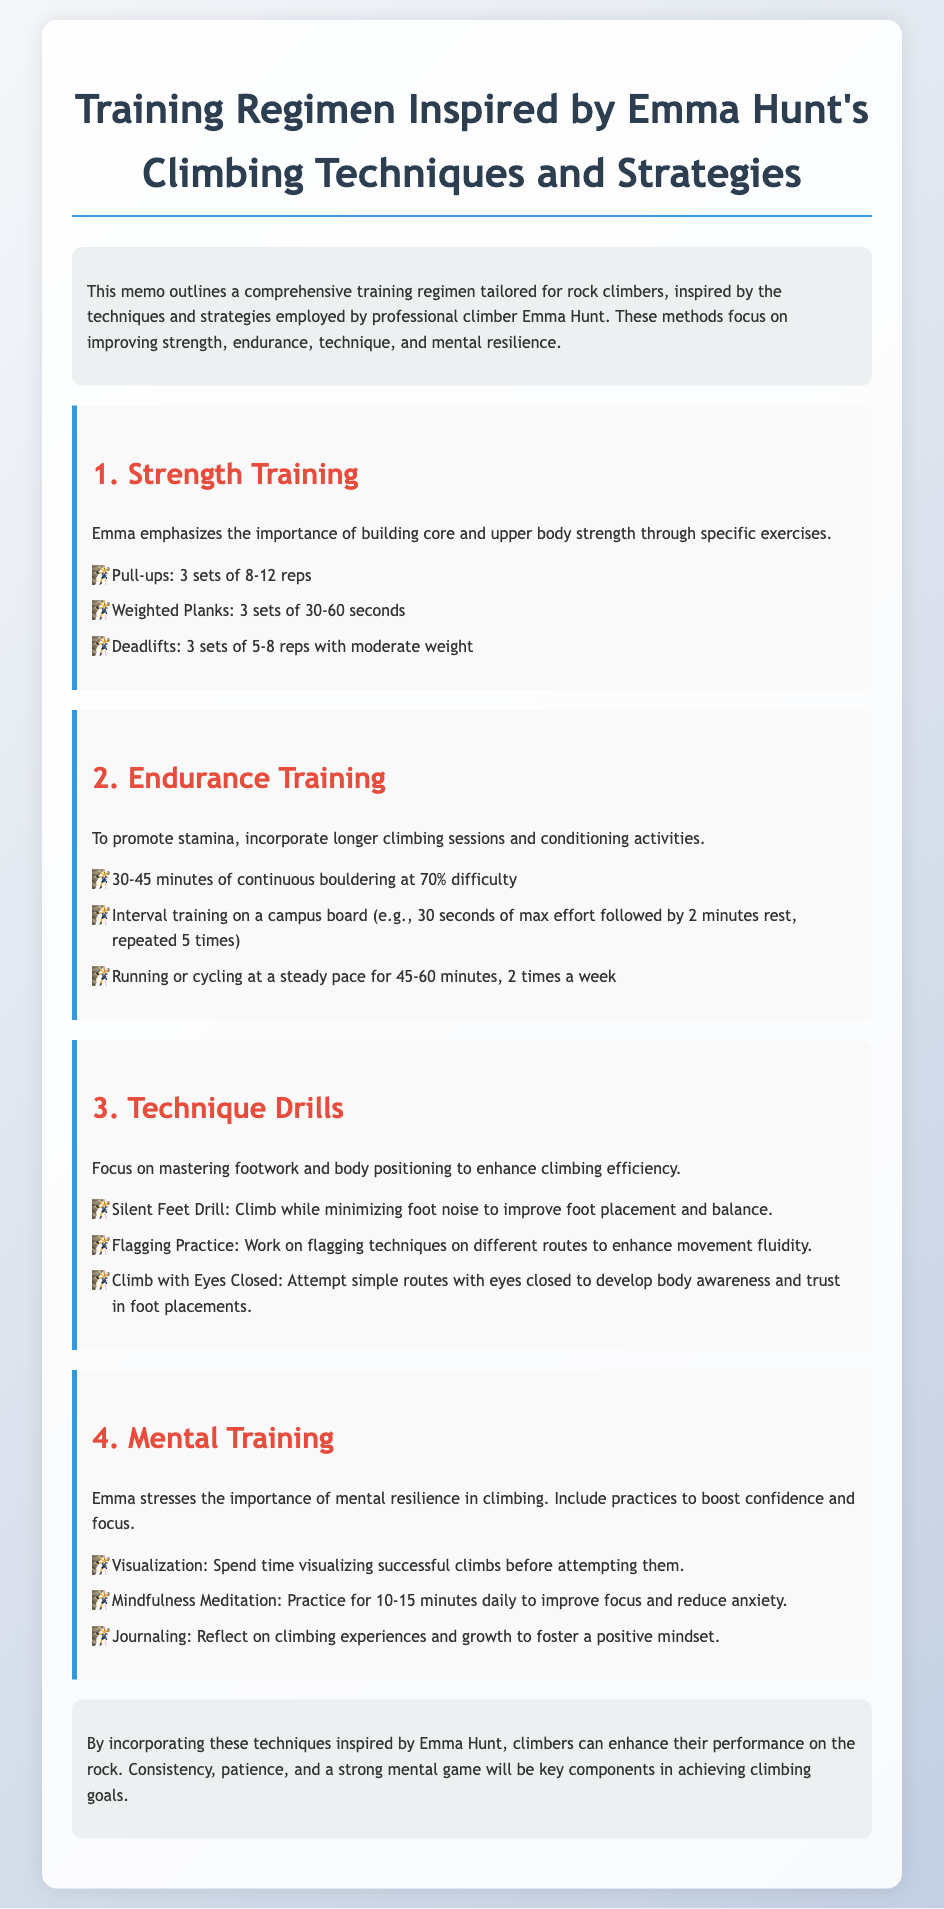What is the title of the document? The title is presented prominently at the top of the document, indicating the main focus of the content.
Answer: Training Regimen Inspired by Emma Hunt's Climbing Techniques and Strategies How many sets of pull-ups are recommended? The document specifies the number of sets for pull-ups under the strength training section.
Answer: 3 sets What exercise is suggested for endurance training involving a campus board? The endurance section details an exercise using the campus board with a specific format.
Answer: Interval training What is the duration of mindfulness meditation practice suggested? The mental training section provides a specific duration for mindfulness meditation.
Answer: 10-15 minutes daily Which drill focuses on foot placement? The technique drills section identifies a specific drill aimed at improving foot placement.
Answer: Silent Feet Drill How many times a week should running or cycling be done? The document mentions the frequency of running or cycling in the endurance training section.
Answer: 2 times a week What is the primary focus of the mental training section? The conclusion about the mental training section indicates a central theme.
Answer: Mental resilience What color is used for the section headers? The document's sections are formatted with a specific color for visual emphasis.
Answer: Red 